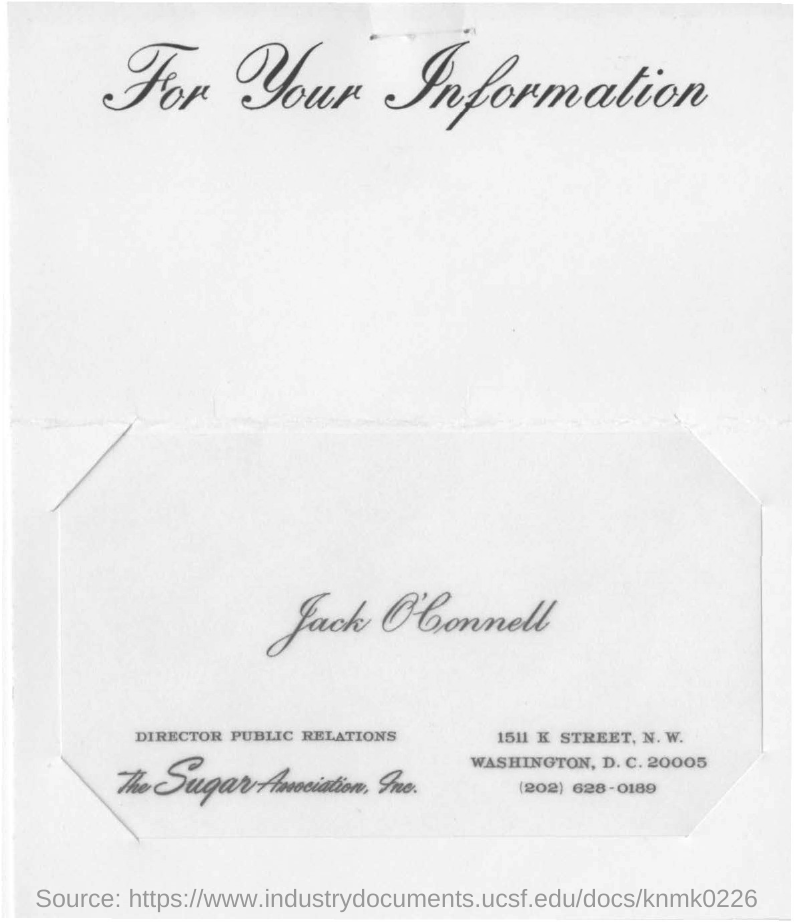Identify some key points in this picture. The location of the person in question is Washington, D.C. The telephone number of Jack O'Connell is (202) 628-0189. Jack O'Connell is the Director of Public Relations. The Director of Public Relations for the Sugar Association, Inc. is Jack O'Connell. 